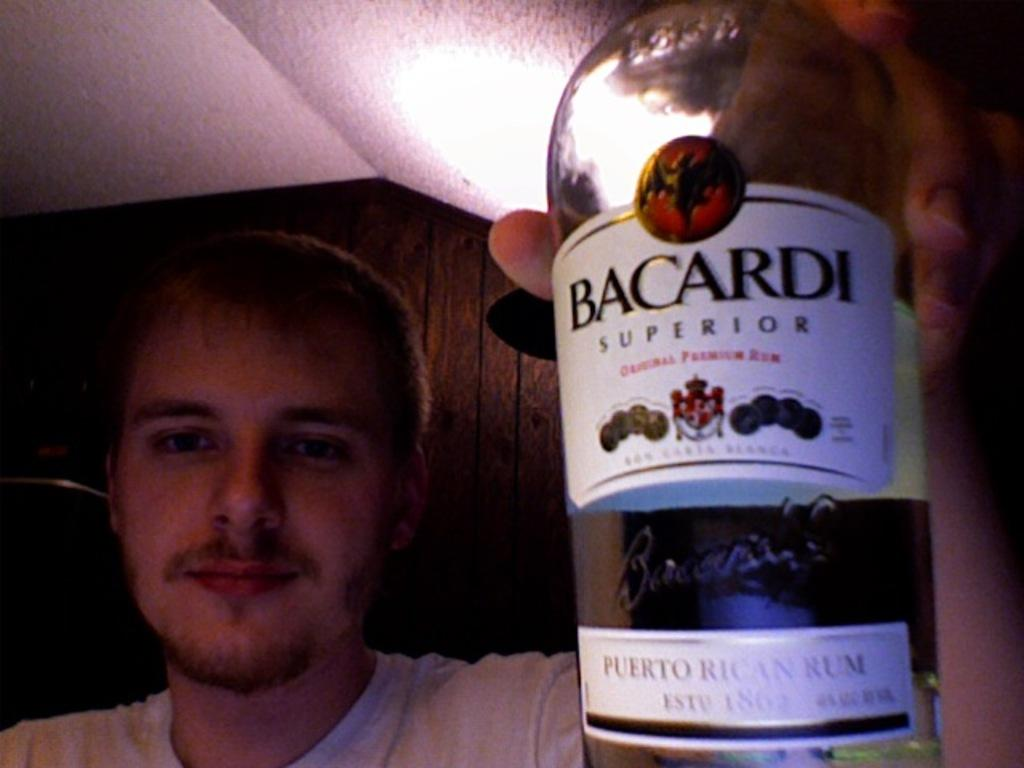<image>
Describe the image concisely. A man holds up a bottle of Bacardi on camera. 